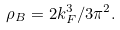<formula> <loc_0><loc_0><loc_500><loc_500>\rho _ { B } = 2 k _ { F } ^ { 3 } / 3 \pi ^ { 2 } .</formula> 